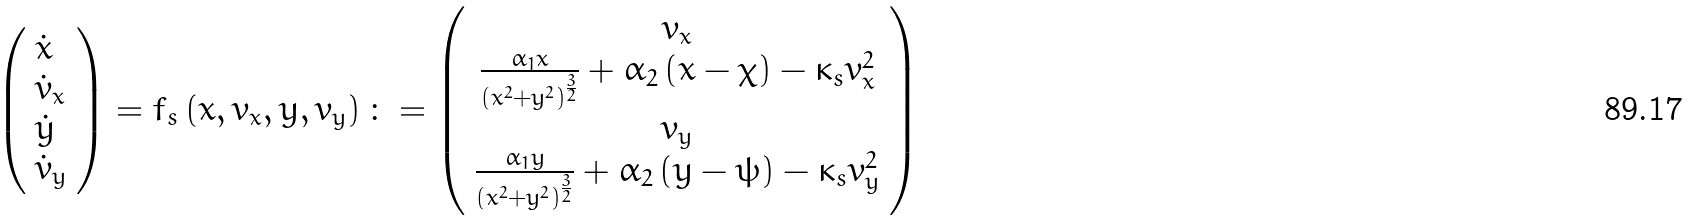<formula> <loc_0><loc_0><loc_500><loc_500>\left ( \begin{array} { l } \dot { x } \\ \dot { v } _ { x } \\ \dot { y } \\ \dot { v } _ { y } \end{array} \right ) = f _ { s } \left ( x , v _ { x } , y , v _ { y } \right ) \colon = \left ( \begin{array} { c } v _ { x } \\ \frac { \alpha _ { 1 } x } { \left ( x ^ { 2 } + y ^ { 2 } \right ) ^ { \frac { 3 } { 2 } } } + \alpha _ { 2 } \left ( x - \chi \right ) - \kappa _ { s } v _ { x } ^ { 2 } \\ v _ { y } \\ \frac { \alpha _ { 1 } y } { \left ( x ^ { 2 } + y ^ { 2 } \right ) ^ { \frac { 3 } { 2 } } } + \alpha _ { 2 } \left ( y - \psi \right ) - \kappa _ { s } v _ { y } ^ { 2 } \end{array} \right )</formula> 